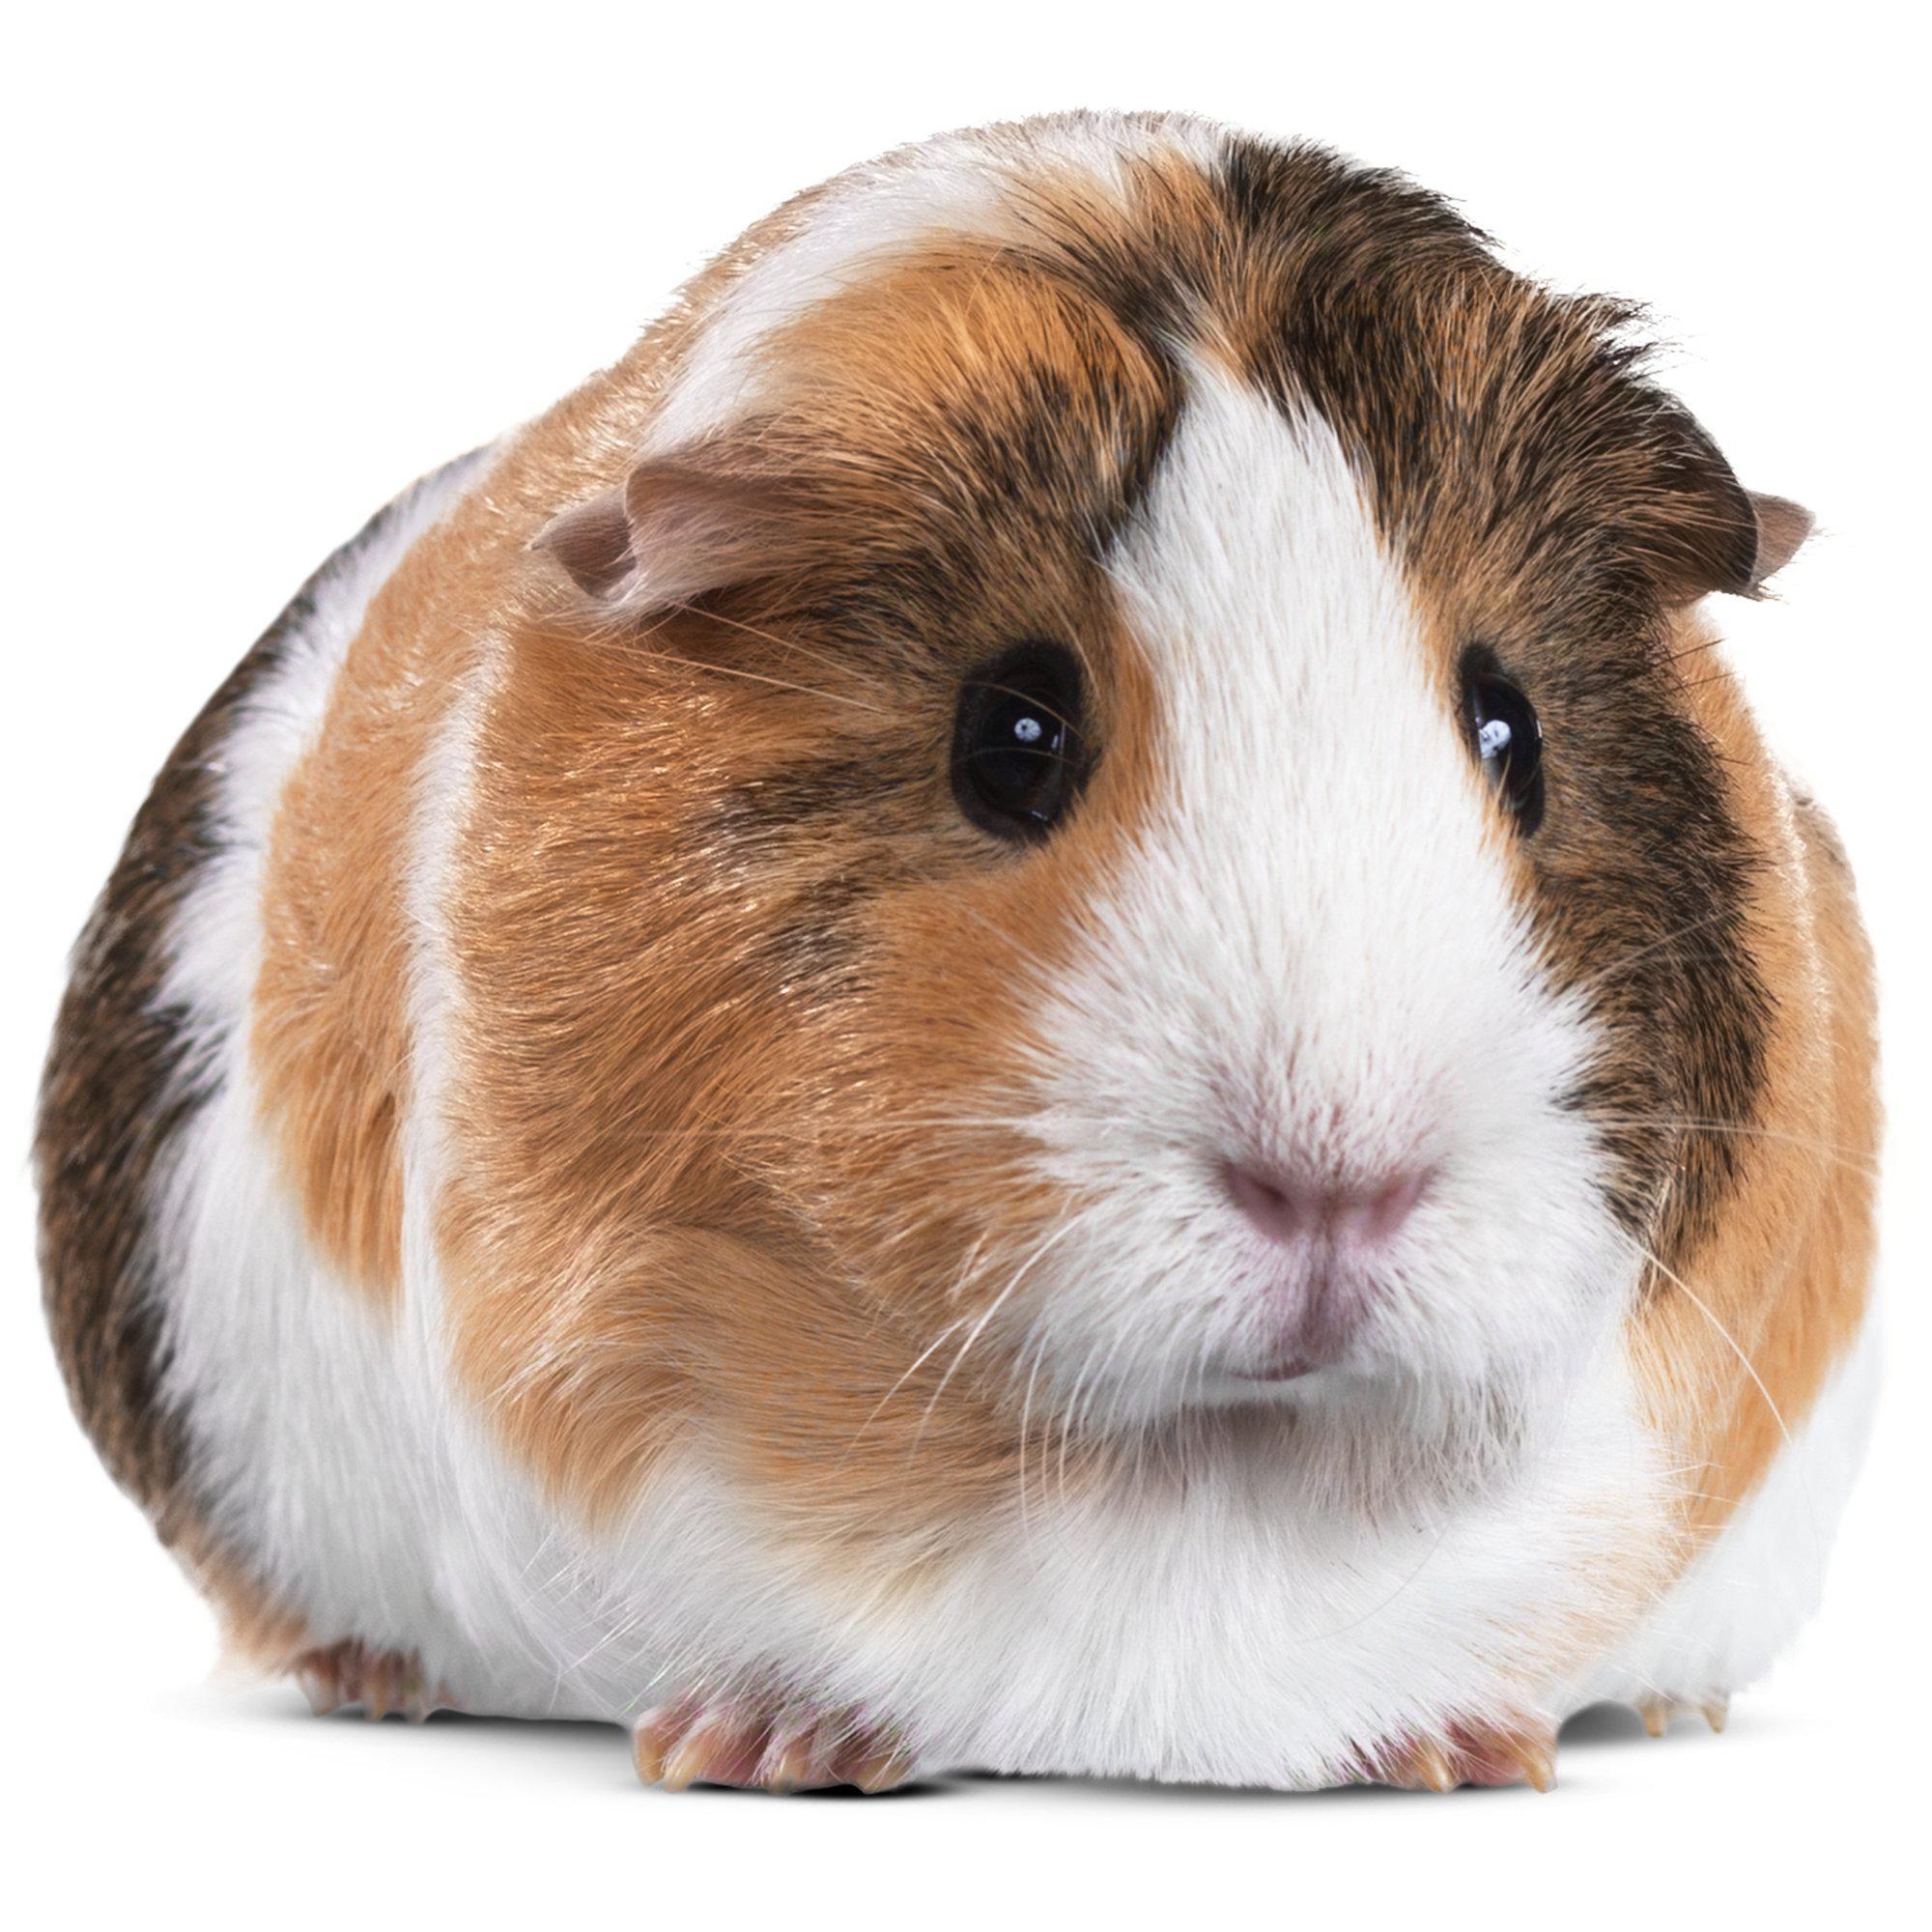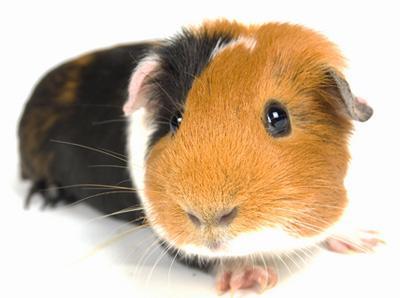The first image is the image on the left, the second image is the image on the right. For the images shown, is this caption "The right image contains at least two guinea pigs." true? Answer yes or no. No. The first image is the image on the left, the second image is the image on the right. Considering the images on both sides, is "The right image contains at least twice as many guinea pigs as the left image." valid? Answer yes or no. No. The first image is the image on the left, the second image is the image on the right. Examine the images to the left and right. Is the description "At least one of the animals is sitting on a soft cushioned material." accurate? Answer yes or no. No. 